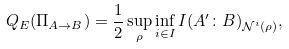Convert formula to latex. <formula><loc_0><loc_0><loc_500><loc_500>Q _ { E } ( \Pi _ { A \rightarrow B } ) = \frac { 1 } { 2 } \sup _ { \rho } \inf _ { i \in I } I ( A ^ { \prime } \colon B ) _ { \mathcal { N } ^ { i } ( \rho ) } ,</formula> 